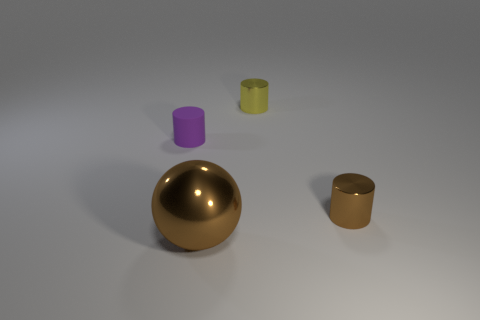Subtract all metal cylinders. How many cylinders are left? 1 Subtract all cylinders. How many objects are left? 1 Add 3 big spheres. How many objects exist? 7 Add 3 yellow things. How many yellow things are left? 4 Add 2 small purple cylinders. How many small purple cylinders exist? 3 Subtract all purple cylinders. How many cylinders are left? 2 Subtract 0 green cylinders. How many objects are left? 4 Subtract 1 spheres. How many spheres are left? 0 Subtract all brown cylinders. Subtract all cyan balls. How many cylinders are left? 2 Subtract all gray balls. How many brown cylinders are left? 1 